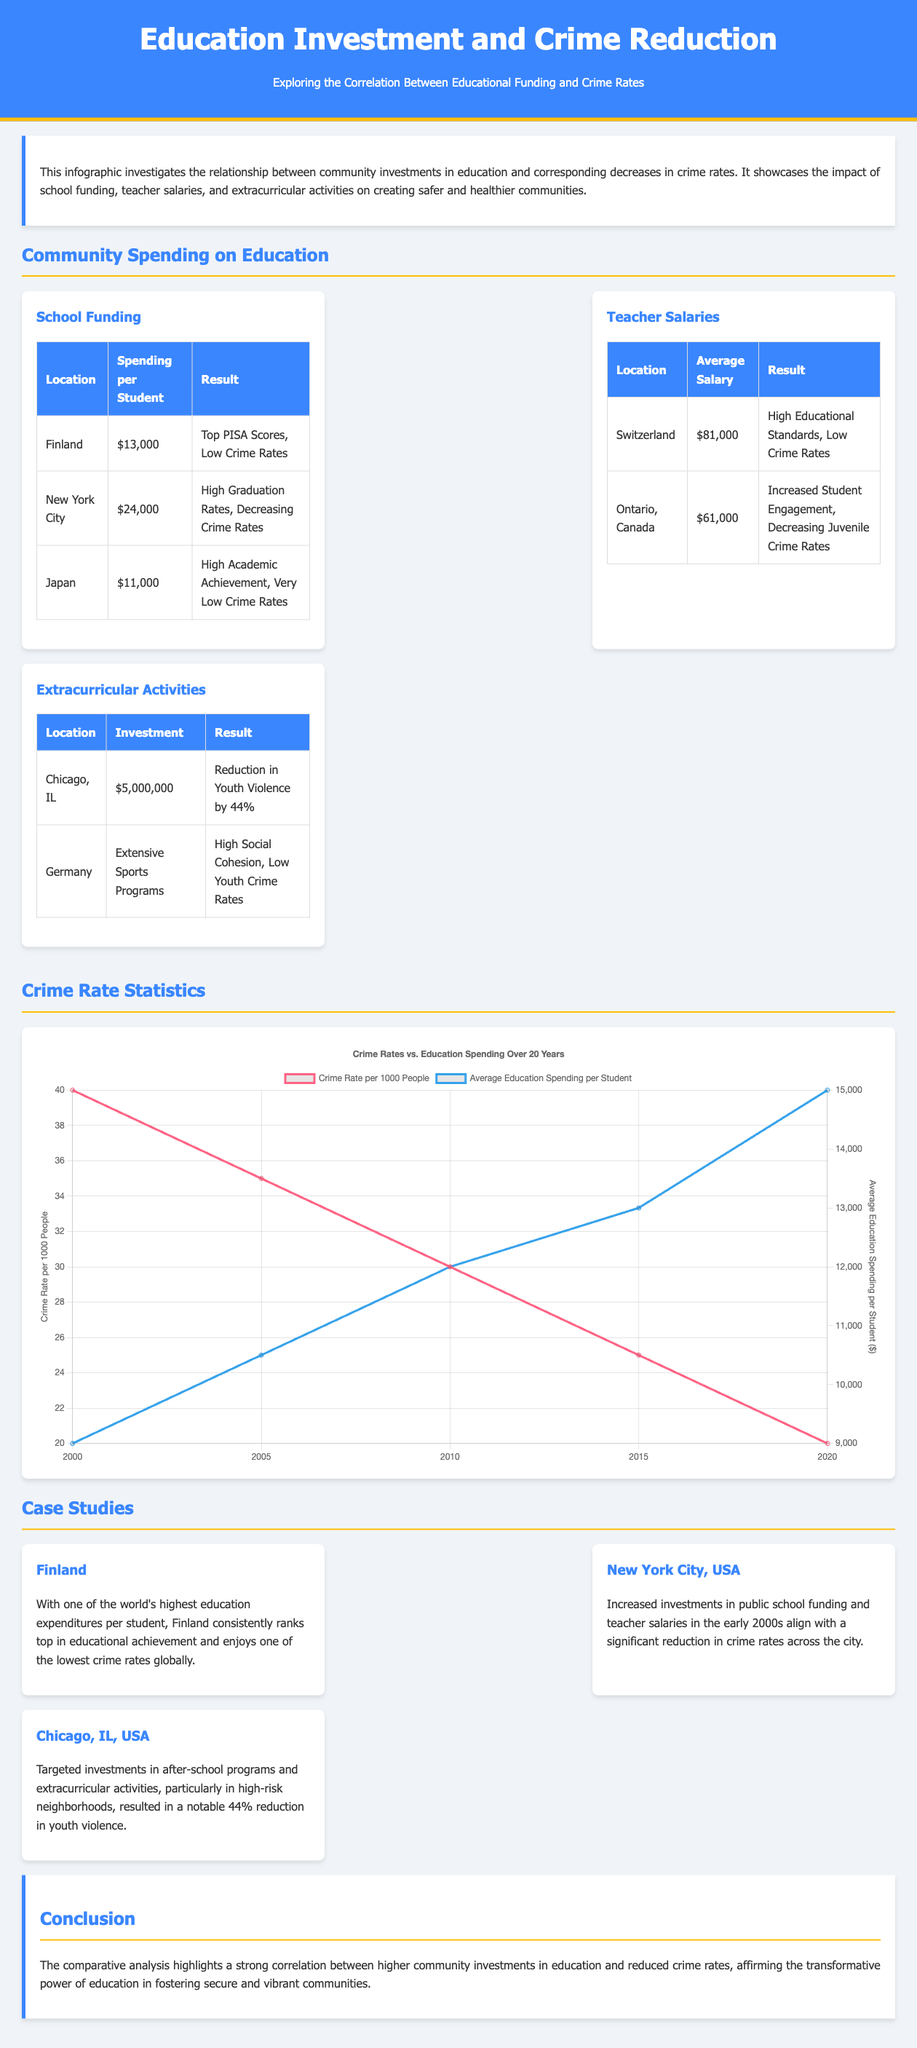What is the average spending per student in Finland? The average spending per student in Finland is detailed in the school funding section of the document, which states it is $13,000.
Answer: $13,000 What was the reduction in youth violence in Chicago, IL due to extracurricular activities? The document states that there was a reduction in youth violence by 44% due to targeted investments in after-school programs.
Answer: 44% Which country has the highest teacher salary mentioned? The teacher salaries section mentions Switzerland with an average salary of $81,000, which is the highest listed.
Answer: Switzerland What major trend is highlighted in the crime rate statistics over 20 years? The line chart illustrates a decreasing trend in crime rates as educational spending increases over the years.
Answer: Decreasing trend What was the investment in extracurricular activities in Chicago, IL? The sports and extracurricular activities section specifically mentions an investment of $5,000,000 in Chicago, IL.
Answer: $5,000,000 What does the conclusion emphasize about education and crime rates? The conclusion draws attention to the strong correlation between higher community investments in education and reduced crime rates, emphasizing education's transformative power.
Answer: Transformative power of education What is the spending per student in New York City? The spending per student in New York City is specified as $24,000 according to the information under school funding.
Answer: $24,000 What type of programs contributed to low crime rates in Germany? The document states that extensive sports programs contribute to high social cohesion and low youth crime rates in Germany.
Answer: Extensive sports programs 